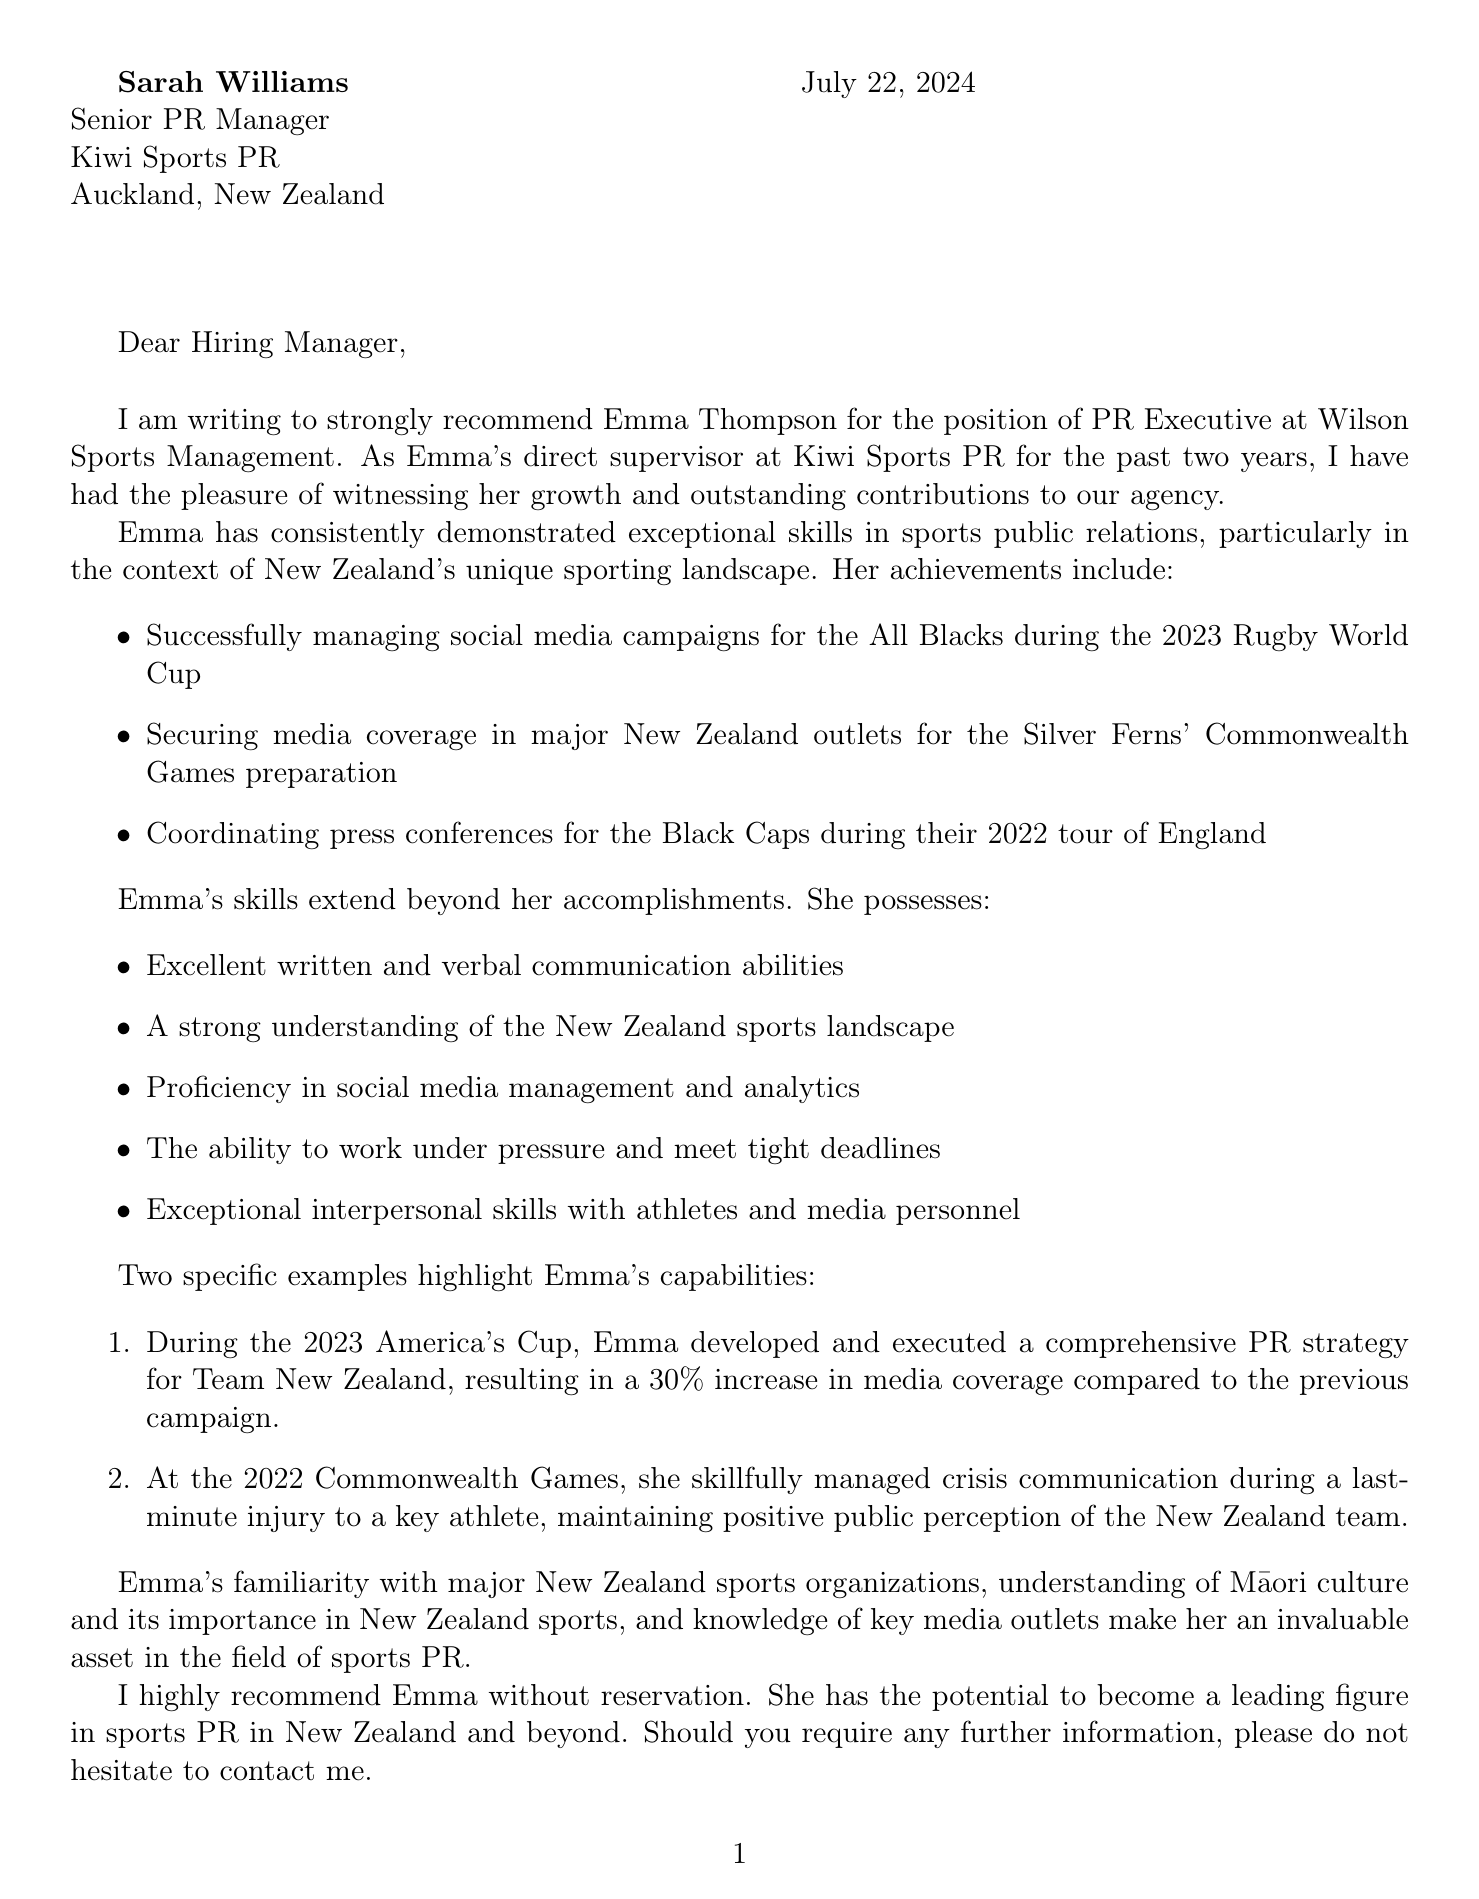What is the name of the candidate? The candidate's name is mentioned at the beginning of the letter, which is Emma Thompson.
Answer: Emma Thompson Who is the writer of the letter? The writer of the letter introduces themselves as Sarah Williams.
Answer: Sarah Williams What is the current position of Emma Thompson? The document specifies that Emma is currently a Junior PR Associate.
Answer: Junior PR Associate How many years of experience does Emma have? Emma's experience is highlighted in the document as being 2 years.
Answer: 2 What position is Emma applying for? The letter states that Emma is seeking a position as a PR Executive.
Answer: PR Executive What sports organization did Emma manage social media campaigns for? The letter mentions that Emma managed campaigns for the All Blacks.
Answer: All Blacks What percentage increase in media coverage did Emma achieve for Team New Zealand? The document indicates a 30% increase in media coverage for Team New Zealand.
Answer: 30% What ability is highlighted for Emma regarding media personnel? The document notes that Emma has exceptional interpersonal skills with media personnel.
Answer: Exceptional interpersonal skills What is the conclusion of the recommendation? The conclusion of the recommendation is a strong endorsement of Emma, stating she is highly recommended without reservation.
Answer: Highly recommend without reservation 